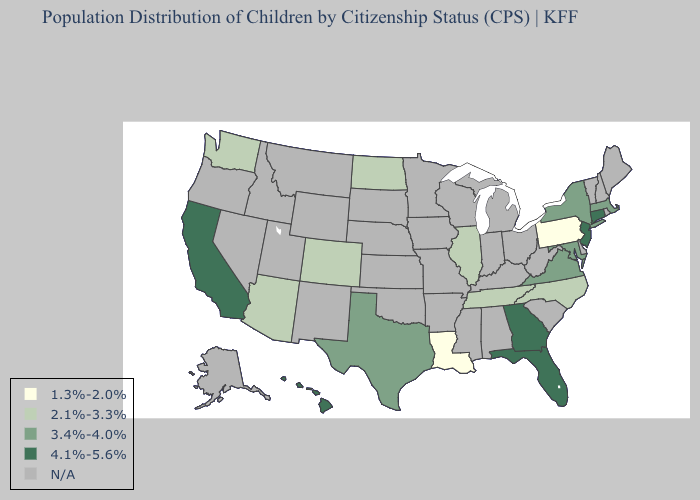Name the states that have a value in the range N/A?
Quick response, please. Alabama, Alaska, Arkansas, Delaware, Idaho, Indiana, Iowa, Kansas, Kentucky, Maine, Michigan, Minnesota, Mississippi, Missouri, Montana, Nebraska, Nevada, New Hampshire, New Mexico, Ohio, Oklahoma, Oregon, Rhode Island, South Carolina, South Dakota, Utah, Vermont, West Virginia, Wisconsin, Wyoming. Name the states that have a value in the range 2.1%-3.3%?
Write a very short answer. Arizona, Colorado, Illinois, North Carolina, North Dakota, Tennessee, Washington. Name the states that have a value in the range 1.3%-2.0%?
Keep it brief. Louisiana, Pennsylvania. What is the lowest value in states that border Arkansas?
Keep it brief. 1.3%-2.0%. Name the states that have a value in the range 1.3%-2.0%?
Write a very short answer. Louisiana, Pennsylvania. Does the first symbol in the legend represent the smallest category?
Be succinct. Yes. What is the value of Maryland?
Answer briefly. 3.4%-4.0%. What is the lowest value in states that border Colorado?
Give a very brief answer. 2.1%-3.3%. Does Massachusetts have the highest value in the Northeast?
Be succinct. No. Name the states that have a value in the range 1.3%-2.0%?
Write a very short answer. Louisiana, Pennsylvania. What is the highest value in states that border New Jersey?
Write a very short answer. 3.4%-4.0%. What is the value of Idaho?
Quick response, please. N/A. Which states have the lowest value in the USA?
Answer briefly. Louisiana, Pennsylvania. 